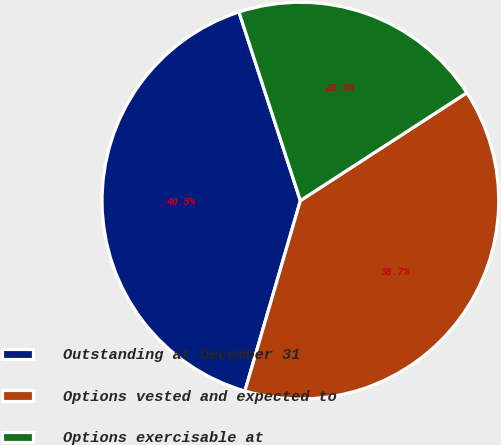Convert chart to OTSL. <chart><loc_0><loc_0><loc_500><loc_500><pie_chart><fcel>Outstanding at December 31<fcel>Options vested and expected to<fcel>Options exercisable at<nl><fcel>40.47%<fcel>38.66%<fcel>20.86%<nl></chart> 